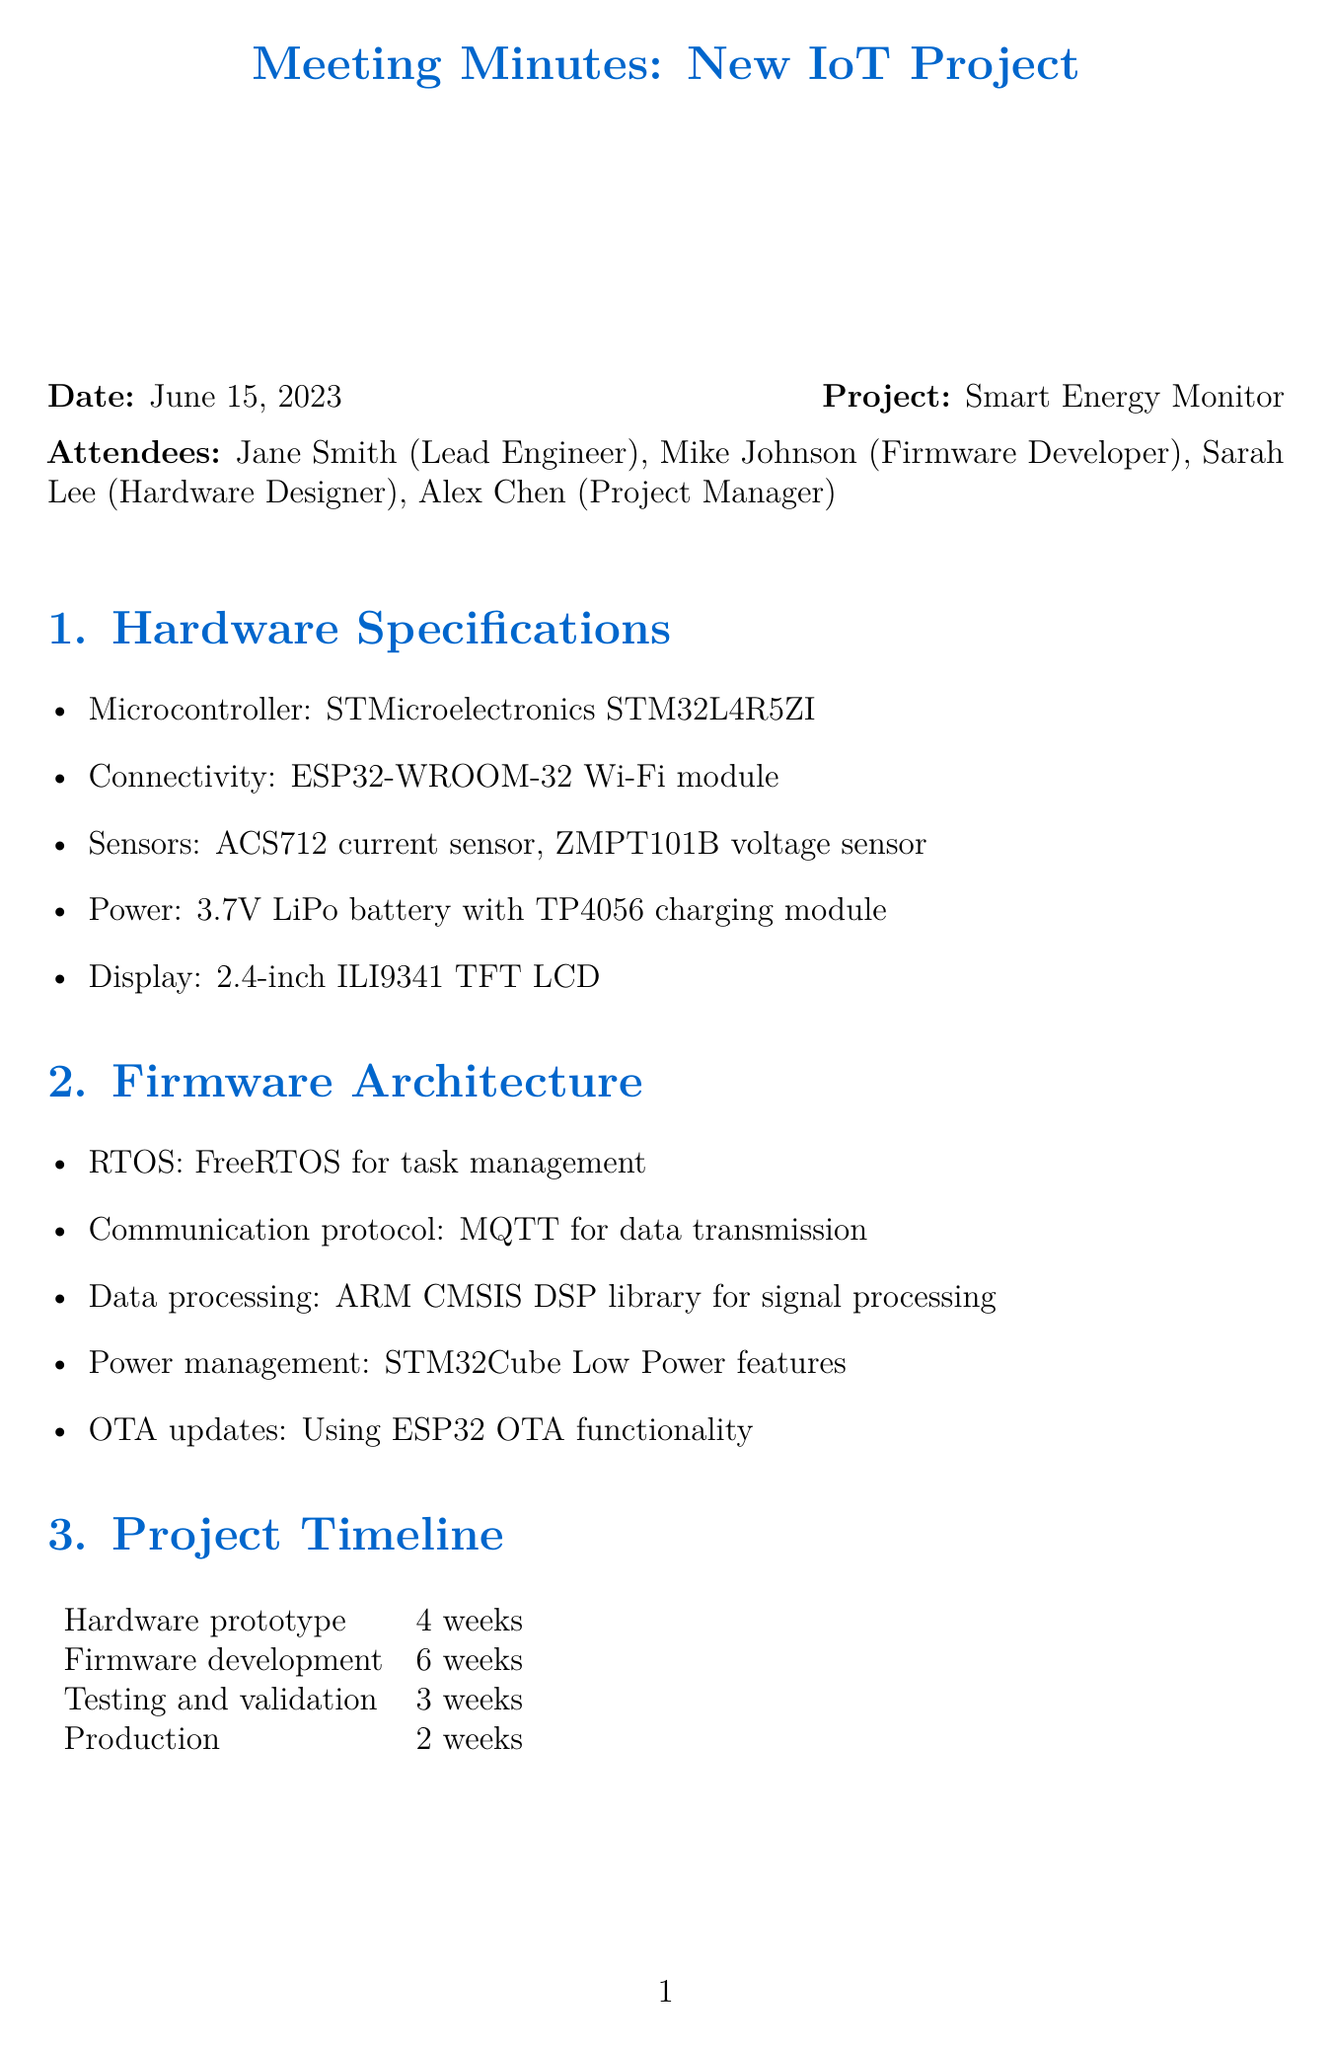What is the microcontroller used in the project? The microcontroller specified in the document is the STMicroelectronics STM32L4R5ZI.
Answer: STMicroelectronics STM32L4R5ZI Which communication protocol is used for data transmission? The document states that MQTT is the chosen communication protocol for data transmission.
Answer: MQTT How long is the firmware development phase scheduled for? The timeline section details that firmware development is expected to take 6 weeks.
Answer: 6 weeks Who is responsible for finalizing the PCB design? According to the action items, Sarah is tasked with finalizing the PCB design.
Answer: Sarah What type of display is included in the hardware specifications? The document specifies that a 2.4-inch ILI9341 TFT LCD is included as part of the hardware.
Answer: 2.4-inch ILI9341 TFT LCD How many weeks are allocated for testing and validation? The project timeline indicates that testing and validation will take 3 weeks.
Answer: 3 weeks What power source is proposed for the project? The proposed power source mentioned is a 3.7V LiPo battery with a TP4056 charging module.
Answer: 3.7V LiPo battery with TP4056 charging module Which RTOS is being used for task management? The firmware architecture section states that FreeRTOS is used for task management.
Answer: FreeRTOS What is the role of Alex Chen in the project? The action items indicate that Alex is coordinating with the manufacturing team.
Answer: Coordinate with manufacturing team 